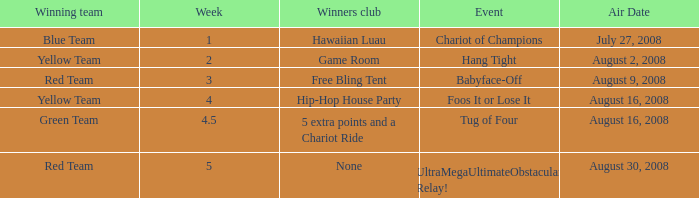Which Week has an Air Date of august 30, 2008? 5.0. 